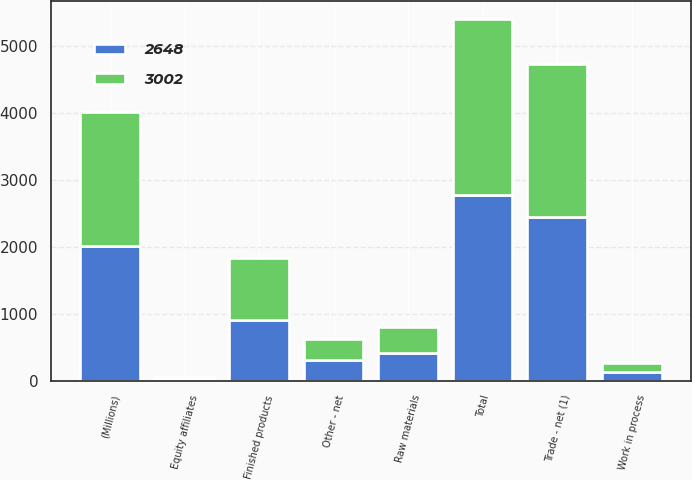Convert chart to OTSL. <chart><loc_0><loc_0><loc_500><loc_500><stacked_bar_chart><ecel><fcel>(Millions)<fcel>Trade - net (1)<fcel>Equity affiliates<fcel>Other - net<fcel>Total<fcel>Finished products<fcel>Work in process<fcel>Raw materials<nl><fcel>2648<fcel>2010<fcel>2447<fcel>24<fcel>307<fcel>2778<fcel>912<fcel>136<fcel>411<nl><fcel>3002<fcel>2009<fcel>2283<fcel>28<fcel>317<fcel>2628<fcel>918<fcel>125<fcel>390<nl></chart> 